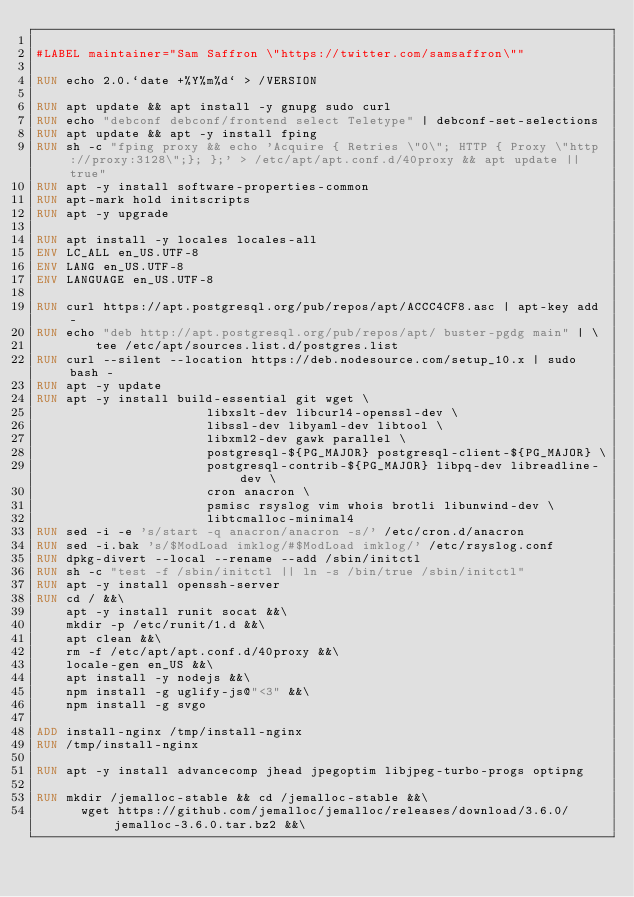Convert code to text. <code><loc_0><loc_0><loc_500><loc_500><_Dockerfile_>
#LABEL maintainer="Sam Saffron \"https://twitter.com/samsaffron\""

RUN echo 2.0.`date +%Y%m%d` > /VERSION

RUN apt update && apt install -y gnupg sudo curl
RUN echo "debconf debconf/frontend select Teletype" | debconf-set-selections
RUN apt update && apt -y install fping
RUN sh -c "fping proxy && echo 'Acquire { Retries \"0\"; HTTP { Proxy \"http://proxy:3128\";}; };' > /etc/apt/apt.conf.d/40proxy && apt update || true"
RUN apt -y install software-properties-common
RUN apt-mark hold initscripts
RUN apt -y upgrade

RUN apt install -y locales locales-all
ENV LC_ALL en_US.UTF-8
ENV LANG en_US.UTF-8
ENV LANGUAGE en_US.UTF-8

RUN curl https://apt.postgresql.org/pub/repos/apt/ACCC4CF8.asc | apt-key add -
RUN echo "deb http://apt.postgresql.org/pub/repos/apt/ buster-pgdg main" | \
        tee /etc/apt/sources.list.d/postgres.list
RUN curl --silent --location https://deb.nodesource.com/setup_10.x | sudo bash -
RUN apt -y update
RUN apt -y install build-essential git wget \
                       libxslt-dev libcurl4-openssl-dev \
                       libssl-dev libyaml-dev libtool \
                       libxml2-dev gawk parallel \
                       postgresql-${PG_MAJOR} postgresql-client-${PG_MAJOR} \
                       postgresql-contrib-${PG_MAJOR} libpq-dev libreadline-dev \
                       cron anacron \
                       psmisc rsyslog vim whois brotli libunwind-dev \
                       libtcmalloc-minimal4
RUN sed -i -e 's/start -q anacron/anacron -s/' /etc/cron.d/anacron
RUN sed -i.bak 's/$ModLoad imklog/#$ModLoad imklog/' /etc/rsyslog.conf
RUN dpkg-divert --local --rename --add /sbin/initctl
RUN sh -c "test -f /sbin/initctl || ln -s /bin/true /sbin/initctl"
RUN apt -y install openssh-server
RUN cd / &&\
    apt -y install runit socat &&\
    mkdir -p /etc/runit/1.d &&\
    apt clean &&\
    rm -f /etc/apt/apt.conf.d/40proxy &&\
    locale-gen en_US &&\
    apt install -y nodejs &&\
    npm install -g uglify-js@"<3" &&\
    npm install -g svgo

ADD install-nginx /tmp/install-nginx
RUN /tmp/install-nginx

RUN apt -y install advancecomp jhead jpegoptim libjpeg-turbo-progs optipng

RUN mkdir /jemalloc-stable && cd /jemalloc-stable &&\
      wget https://github.com/jemalloc/jemalloc/releases/download/3.6.0/jemalloc-3.6.0.tar.bz2 &&\</code> 